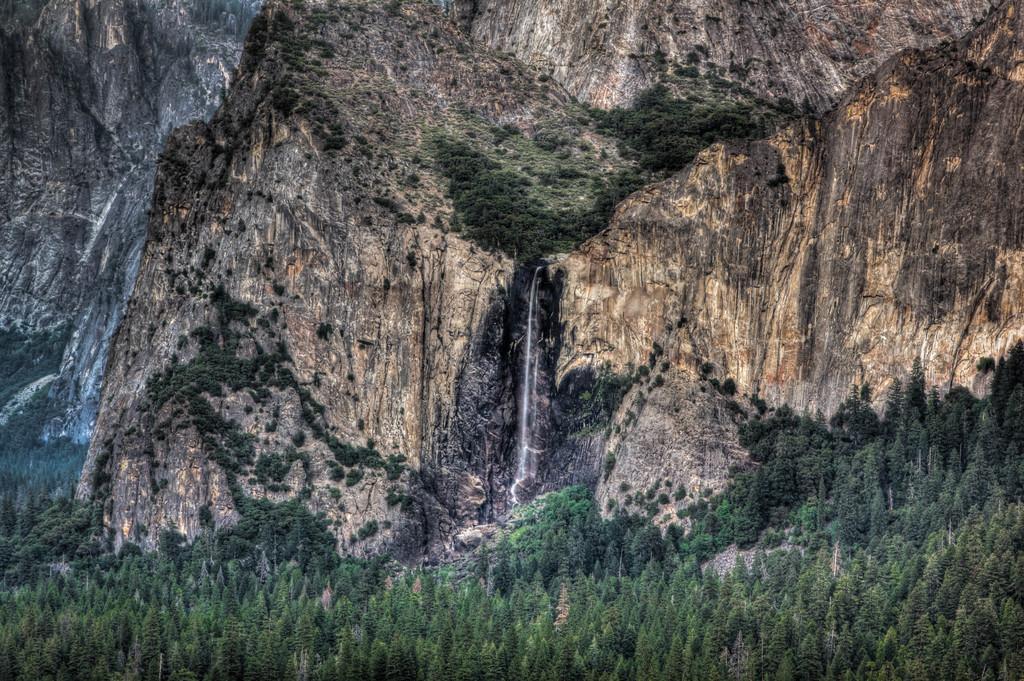Please provide a concise description of this image. This image consists of mountains. In the middle, we can see a waterfall. At the bottom, there are plants. 